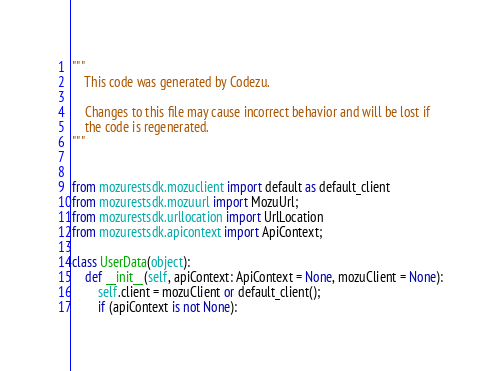Convert code to text. <code><loc_0><loc_0><loc_500><loc_500><_Python_>
"""
    This code was generated by Codezu.     

    Changes to this file may cause incorrect behavior and will be lost if
    the code is regenerated.
"""


from mozurestsdk.mozuclient import default as default_client
from mozurestsdk.mozuurl import MozuUrl;
from mozurestsdk.urllocation import UrlLocation
from mozurestsdk.apicontext import ApiContext;

class UserData(object):
	def __init__(self, apiContext: ApiContext = None, mozuClient = None):
		self.client = mozuClient or default_client();
		if (apiContext is not None):</code> 